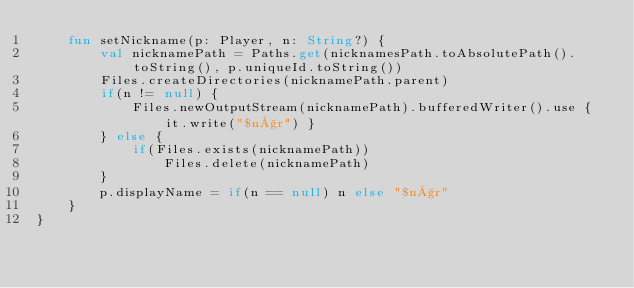<code> <loc_0><loc_0><loc_500><loc_500><_Kotlin_>    fun setNickname(p: Player, n: String?) {
        val nicknamePath = Paths.get(nicknamesPath.toAbsolutePath().toString(), p.uniqueId.toString())
        Files.createDirectories(nicknamePath.parent)
        if(n != null) {
            Files.newOutputStream(nicknamePath).bufferedWriter().use { it.write("$n§r") }
        } else {
            if(Files.exists(nicknamePath))
                Files.delete(nicknamePath)
        }
        p.displayName = if(n == null) n else "$n§r"
    }
}</code> 